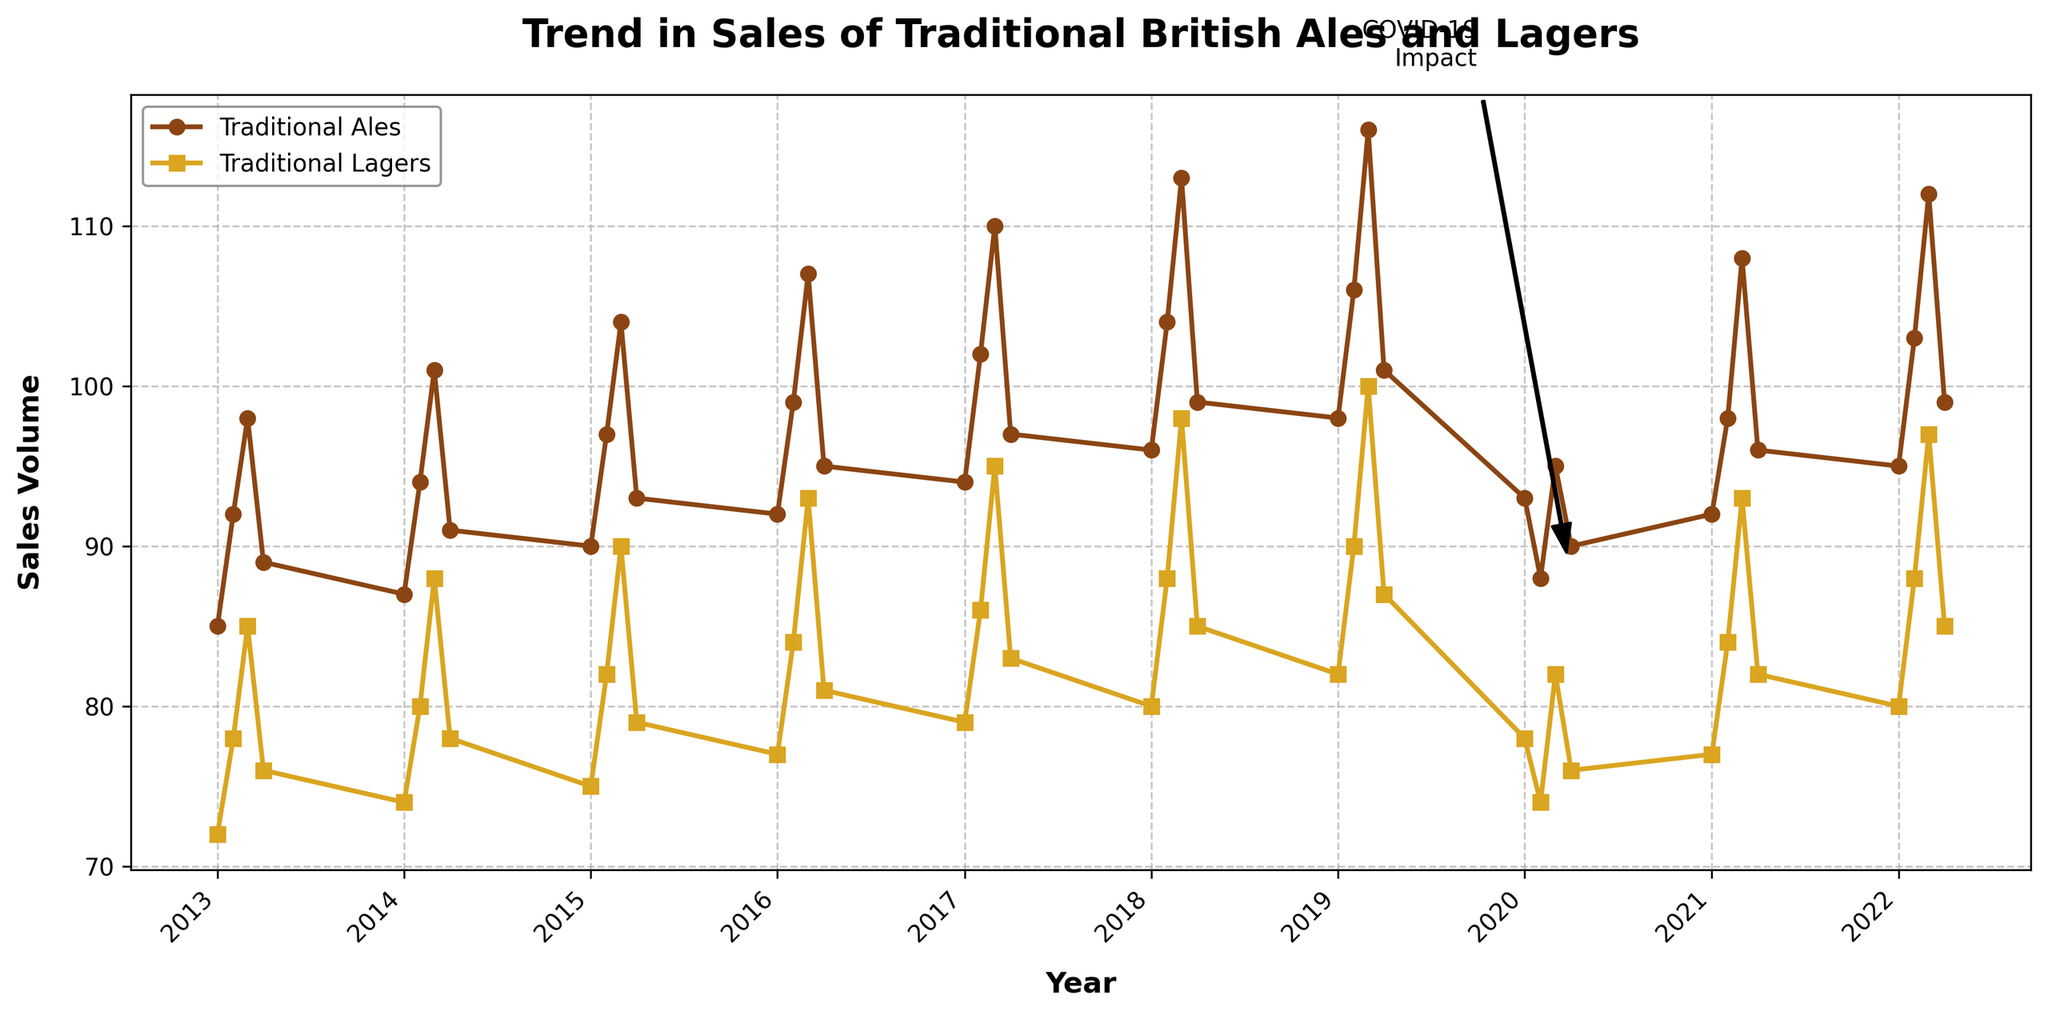How did the sales of Traditional Ales and Traditional Lagers change during Q2 of 2020 compared to Q1 of 2020? To find the change, subtract the Q1 sales figures from the Q2 sales figures for both Ales and Lagers. For Traditional Ales, it's 88 (Q2) - 93 (Q1) = -5. For Traditional Lagers, it's 74 (Q2) - 78 (Q1) = -4.
Answer: Both decreased, Ales by 5 and Lagers by 4 Which quarter in 2019 saw the highest sales of Traditional Lagers, and how much was it? Check each quarter in 2019 and find the highest sales figure. Q1 had 82, Q2 had 90, Q3 had 100, and Q4 had 87. Thus, Q3 had the highest sales for Lagers with 100.
Answer: Q3 with 100 What was the average sales volume of Traditional Ales in 2016? Sum all the sales figures for each quarter in 2016 and divide by the number of quarters. (92 + 99 + 107 + 95) / 4 = 393 / 4 = 98.25
Answer: 98.25 Compare the trends in sales for Traditional Ales and Traditional Lagers from 2013 to 2022. Which one showed a steadier increase? Look at the line trends from 2013 to 2022. Ales generally show a consistent upward trend with fewer fluctuations, while Lagers have some dips, especially around 2020.
Answer: Ales showed a steadier increase By how much did the sales of Traditional Ales increase from Q1 2013 to Q3 2022? Subtract the sales in Q1 2013 from sales in Q3 2022. It's 112 (Q3 2022) - 85 (Q1 2013) = 27.
Answer: Increased by 27 What color represents Traditional Ales on the plot? Observe the colors used in the graph. The line and markers for Traditional Ales are brown.
Answer: Brown During which year did the sales of Traditional Ales peak, and what was the value? Review each year to find the highest value. The peak was in Q3 2019 with a value of 116.
Answer: 2019 with 116 What visual indicator marks the COVID-19 impact on the plot? Identify any annotations or arrows pointing to specific points on the graph. There is an annotation and arrow labeled "COVID-19 Impact" pointing to Q2 2020.
Answer: An annotation and arrow labeled "COVID-19 Impact" Is there a significant sales dip for both Traditional Ales and Traditional Lagers? If yes, when did it occur? Look for the steepest decline in the lines representing the sales. Both products see a significant dip in Q2 2020.
Answer: Yes, in Q2 2020 Did Traditional Lagers ever surpass Traditional Ales in sales over the years? Compare both lines year by year. Traditional Lagers never surpassed Traditional Ales in sales in any quarter.
Answer: No 